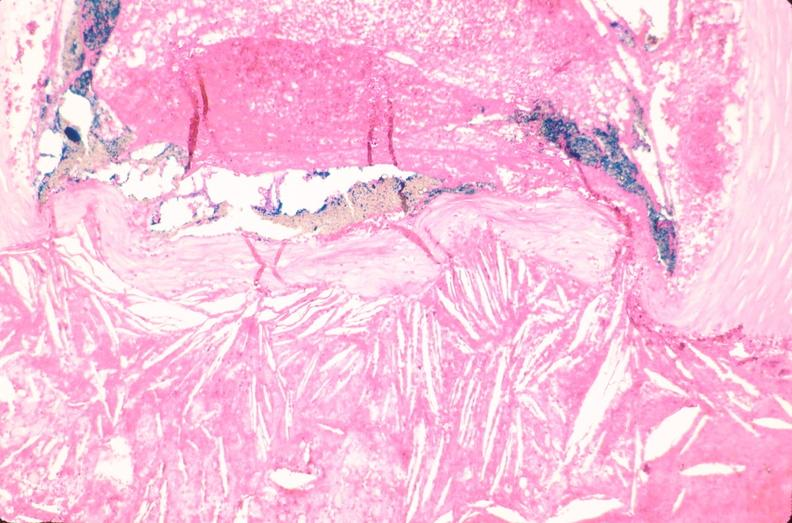s papillary intraductal adenocarcinoma present?
Answer the question using a single word or phrase. No 